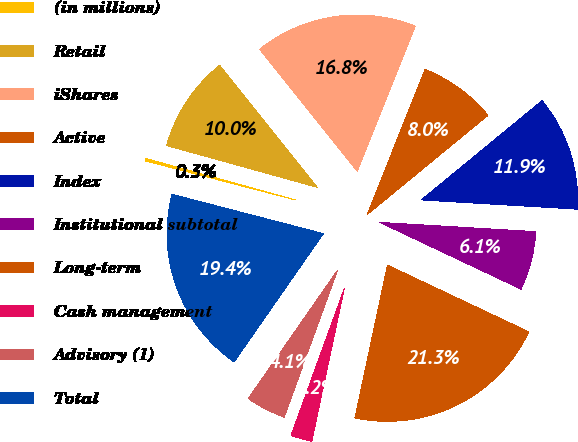Convert chart to OTSL. <chart><loc_0><loc_0><loc_500><loc_500><pie_chart><fcel>(in millions)<fcel>Retail<fcel>iShares<fcel>Active<fcel>Index<fcel>Institutional subtotal<fcel>Long-term<fcel>Cash management<fcel>Advisory (1)<fcel>Total<nl><fcel>0.26%<fcel>9.95%<fcel>16.78%<fcel>8.01%<fcel>11.89%<fcel>6.08%<fcel>21.31%<fcel>2.2%<fcel>4.14%<fcel>19.37%<nl></chart> 